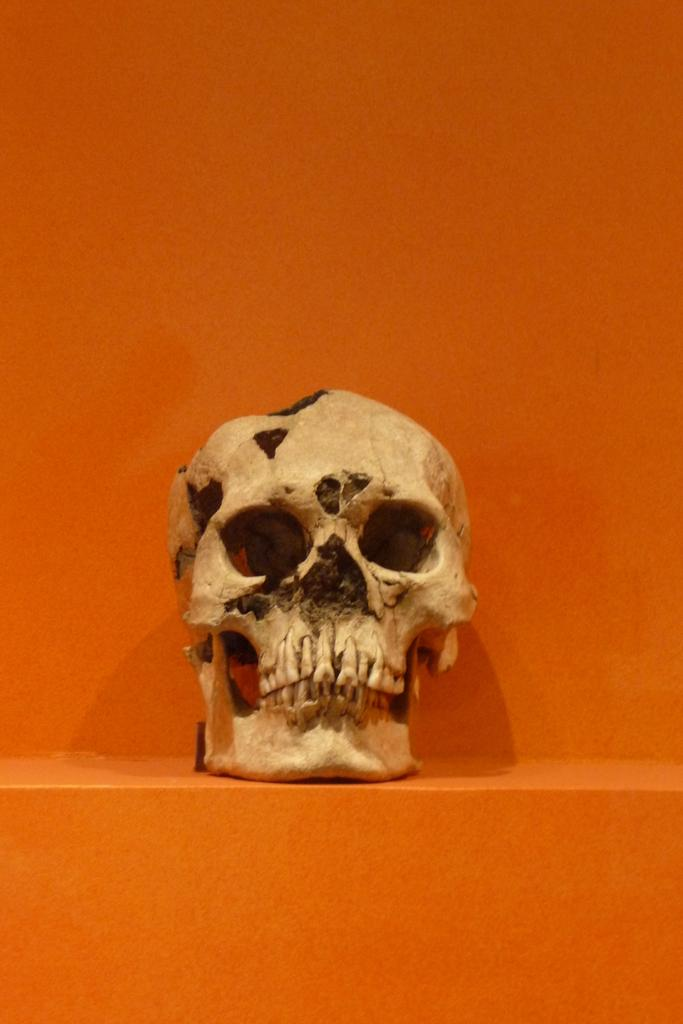What is the main subject of the image? There is a skull in the image. What is the color of the surface on which the skull is placed? The skull is on an orange surface. What can be seen in the background of the image? There is an orange color wall in the background of the image. What type of paste is being sold in the shop depicted in the image? There is no shop or paste present in the image; it features a skull on an orange surface with an orange color wall in the background. 